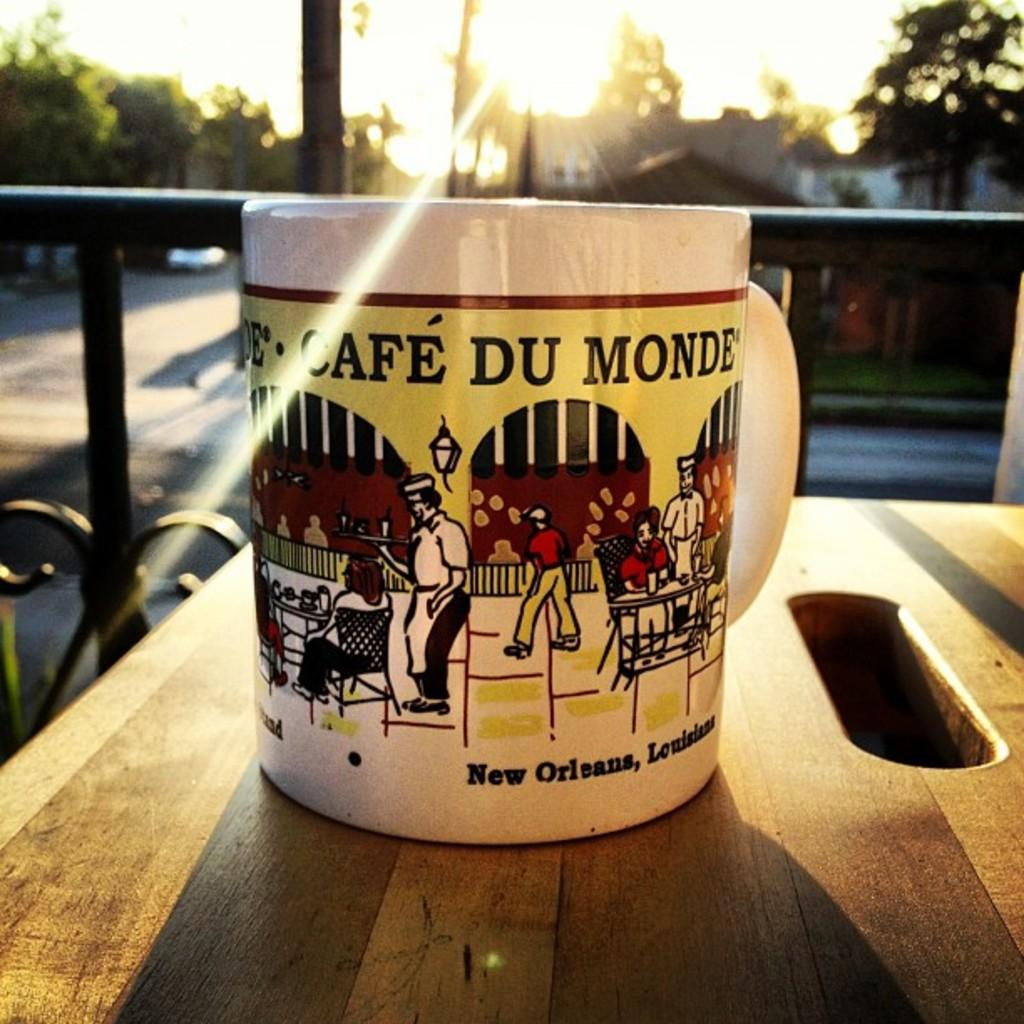<image>
Write a terse but informative summary of the picture. a coffee mug of cafe du monde in new orleans 